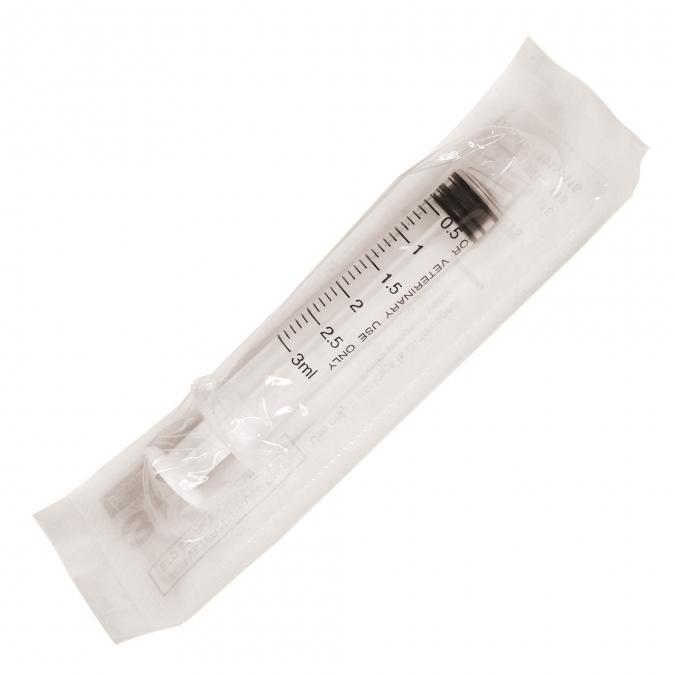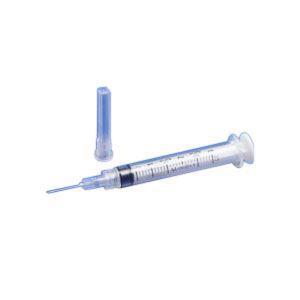The first image is the image on the left, the second image is the image on the right. For the images shown, is this caption "The combined images include a white wrapper and an upright blue lid behind a syringe with an exposed tip." true? Answer yes or no. Yes. The first image is the image on the left, the second image is the image on the right. Assess this claim about the two images: "A blue cap is next to at least 1 syringe with a needle.". Correct or not? Answer yes or no. Yes. 